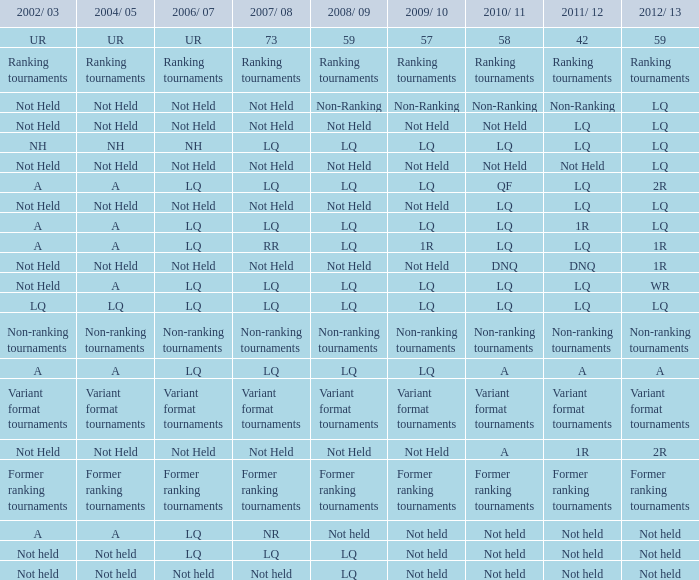Identify the 2009/10 to 2011/12 of a LQ. 